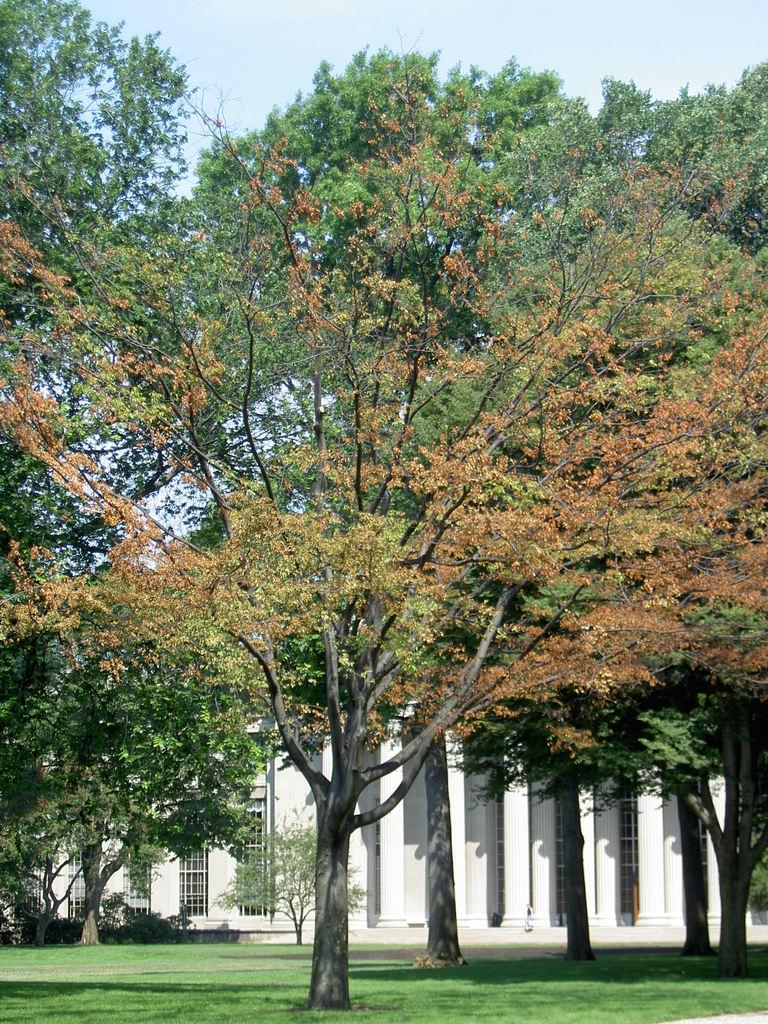What type of surface is visible in the image? There is a ground in the image. What type of vegetation can be seen in the image? There are trees in the image. What type of structure is present in the image? There is a building in the image. What is the condition of the sky in the image? The sky is clear in the image. What type of veil is draped over the trees in the image? There is no veil present in the image. --- Facts: 1. There is a person in the image. 2. The person is wearing a hat. 3. The person is holding a book. 4. The person is sitting on a chair. 5. There is a table in the image. Absurd Topics: unicorn, magic wand, flying carpet Conversation: Who or what is the main subject in the image? The main subject in the image is a person. What is the person in the image wearing? The person in the image is wearing a hat. What is the person in the image holding? The person in the image is holding a book. What is the person in the image doing? The person in the image is sitting on a chair. What other objects or elements can be seen in the image? There is a table in the image. Reasoning: Let's think step by step in order to produce the conversation. We start by identifying the main subject of the image, which is a person. Next, we describe the person's attire, specifically the hat they are wearing. Then, we observe the actions of the person, noting that they are holding a book. After that, we describe the person's posture, stating that they are sitting on a chair. Finally, we mention any other objects or elements that can be seen in the image, which in this case is a table. Absurd Question/Answer: Can you see a unicorn in the image? No, there is no unicorn present in the image. --- Facts: 1. There is a dog in the image. 2. The dog is lying down on the ground. 3. The dog has a red collar. 4. There is a tree in the background of the image. 5. The sky is visible in the image. Absurd Topics: spaceship, alien creature, laser beams Conversation: What type of animal is present in the image? There is a dog in the image. What is the dog doing in the image? The dog is lying down on the ground in the image. What type of accessory is the dog wearing in the image? The dog has a red collar in the image. What can be seen in the background of the image? There is a tree in the background of the image. What is visible in the image? The sky is visible in the image 